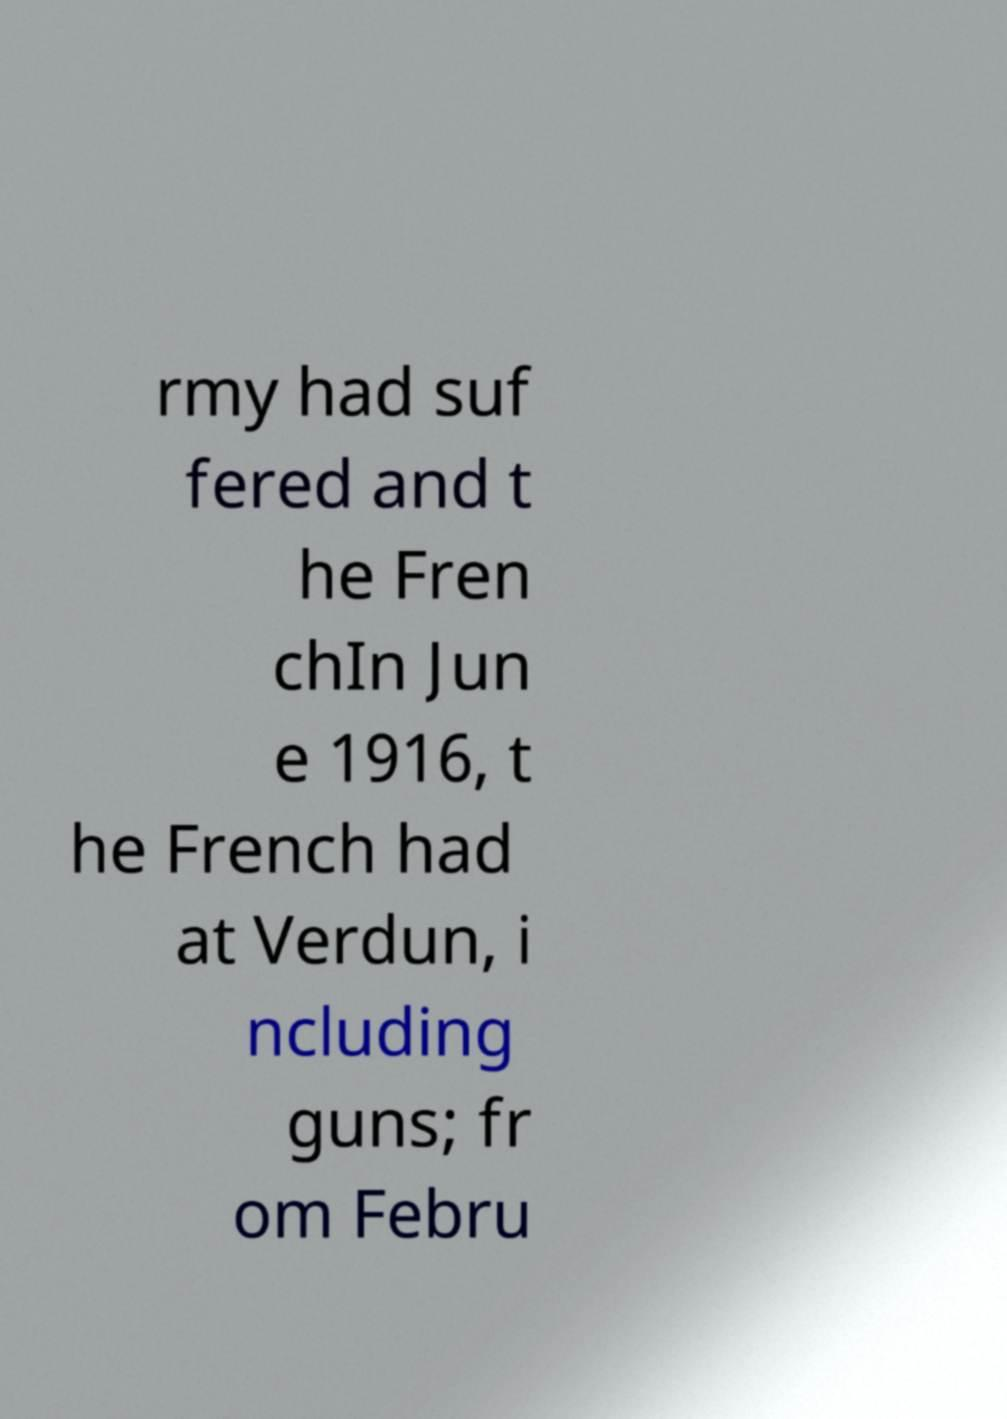For documentation purposes, I need the text within this image transcribed. Could you provide that? rmy had suf fered and t he Fren chIn Jun e 1916, t he French had at Verdun, i ncluding guns; fr om Febru 